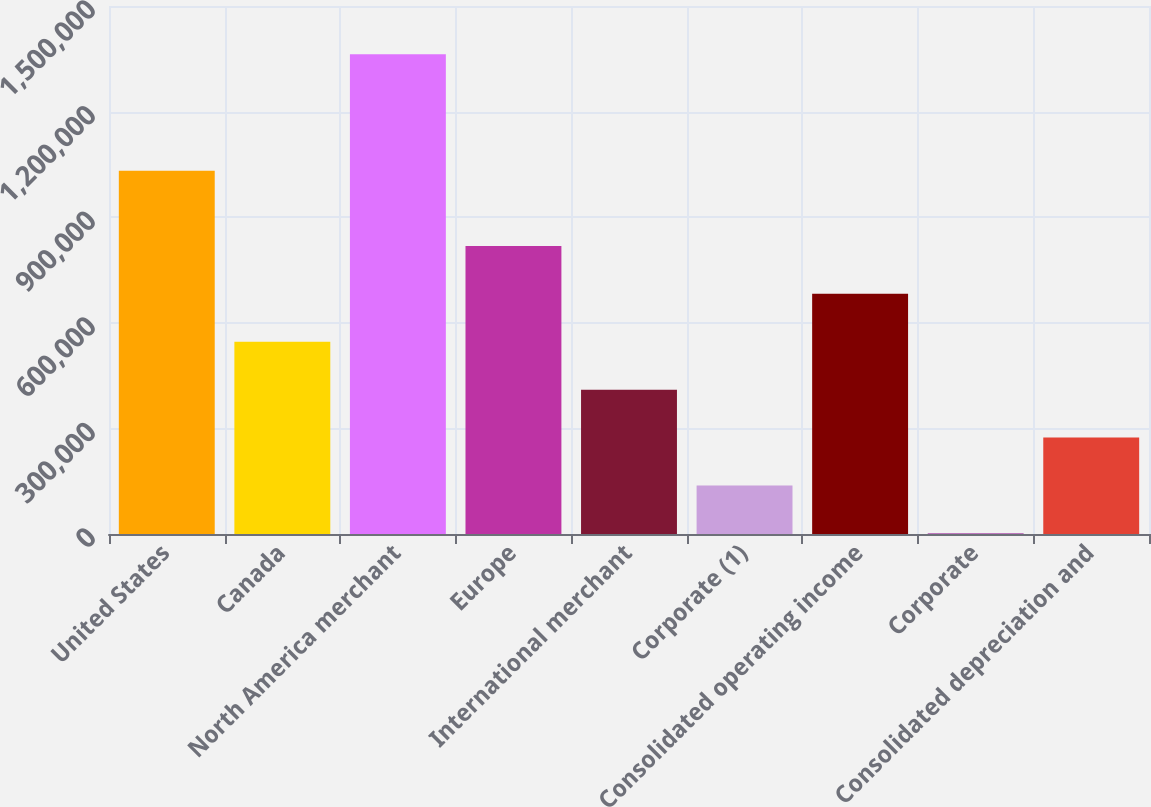<chart> <loc_0><loc_0><loc_500><loc_500><bar_chart><fcel>United States<fcel>Canada<fcel>North America merchant<fcel>Europe<fcel>International merchant<fcel>Corporate (1)<fcel>Consolidated operating income<fcel>Corporate<fcel>Consolidated depreciation and<nl><fcel>1.032e+06<fcel>546064<fcel>1.36287e+06<fcel>818333<fcel>409930<fcel>137662<fcel>682198<fcel>1528<fcel>273796<nl></chart> 